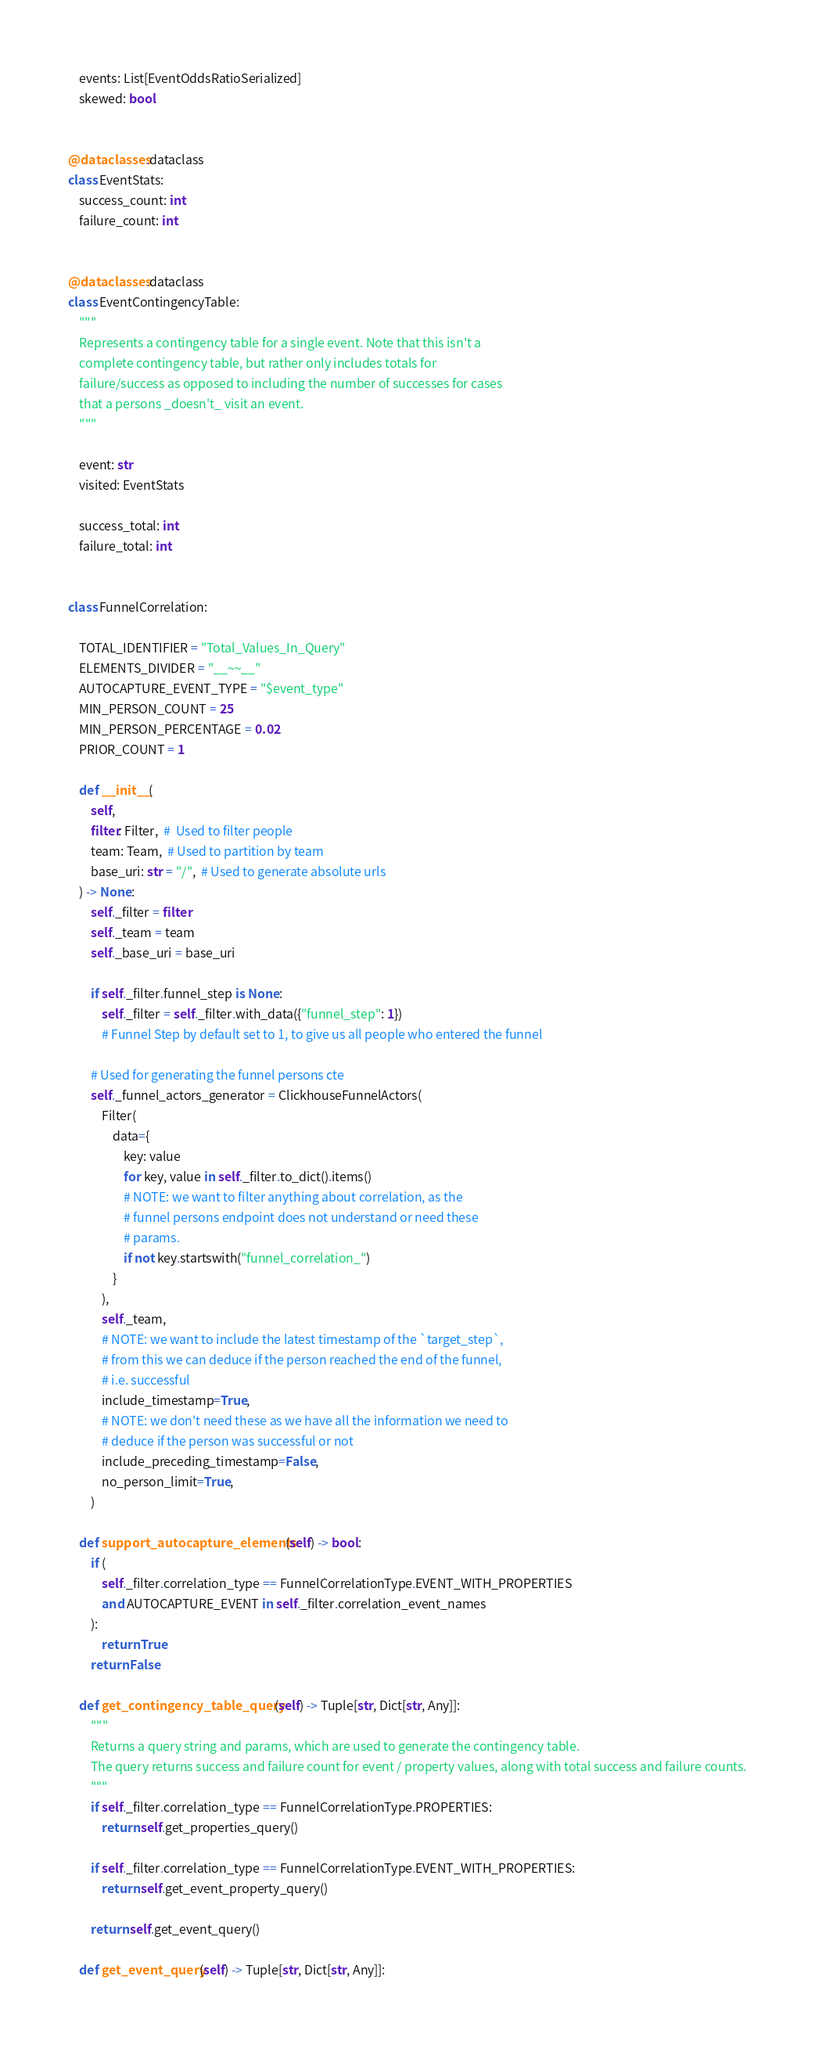<code> <loc_0><loc_0><loc_500><loc_500><_Python_>    events: List[EventOddsRatioSerialized]
    skewed: bool


@dataclasses.dataclass
class EventStats:
    success_count: int
    failure_count: int


@dataclasses.dataclass
class EventContingencyTable:
    """
    Represents a contingency table for a single event. Note that this isn't a
    complete contingency table, but rather only includes totals for
    failure/success as opposed to including the number of successes for cases
    that a persons _doesn't_ visit an event.
    """

    event: str
    visited: EventStats

    success_total: int
    failure_total: int


class FunnelCorrelation:

    TOTAL_IDENTIFIER = "Total_Values_In_Query"
    ELEMENTS_DIVIDER = "__~~__"
    AUTOCAPTURE_EVENT_TYPE = "$event_type"
    MIN_PERSON_COUNT = 25
    MIN_PERSON_PERCENTAGE = 0.02
    PRIOR_COUNT = 1

    def __init__(
        self,
        filter: Filter,  #  Used to filter people
        team: Team,  # Used to partition by team
        base_uri: str = "/",  # Used to generate absolute urls
    ) -> None:
        self._filter = filter
        self._team = team
        self._base_uri = base_uri

        if self._filter.funnel_step is None:
            self._filter = self._filter.with_data({"funnel_step": 1})
            # Funnel Step by default set to 1, to give us all people who entered the funnel

        # Used for generating the funnel persons cte
        self._funnel_actors_generator = ClickhouseFunnelActors(
            Filter(
                data={
                    key: value
                    for key, value in self._filter.to_dict().items()
                    # NOTE: we want to filter anything about correlation, as the
                    # funnel persons endpoint does not understand or need these
                    # params.
                    if not key.startswith("funnel_correlation_")
                }
            ),
            self._team,
            # NOTE: we want to include the latest timestamp of the `target_step`,
            # from this we can deduce if the person reached the end of the funnel,
            # i.e. successful
            include_timestamp=True,
            # NOTE: we don't need these as we have all the information we need to
            # deduce if the person was successful or not
            include_preceding_timestamp=False,
            no_person_limit=True,
        )

    def support_autocapture_elements(self) -> bool:
        if (
            self._filter.correlation_type == FunnelCorrelationType.EVENT_WITH_PROPERTIES
            and AUTOCAPTURE_EVENT in self._filter.correlation_event_names
        ):
            return True
        return False

    def get_contingency_table_query(self) -> Tuple[str, Dict[str, Any]]:
        """
        Returns a query string and params, which are used to generate the contingency table.
        The query returns success and failure count for event / property values, along with total success and failure counts.
        """
        if self._filter.correlation_type == FunnelCorrelationType.PROPERTIES:
            return self.get_properties_query()

        if self._filter.correlation_type == FunnelCorrelationType.EVENT_WITH_PROPERTIES:
            return self.get_event_property_query()

        return self.get_event_query()

    def get_event_query(self) -> Tuple[str, Dict[str, Any]]:
</code> 